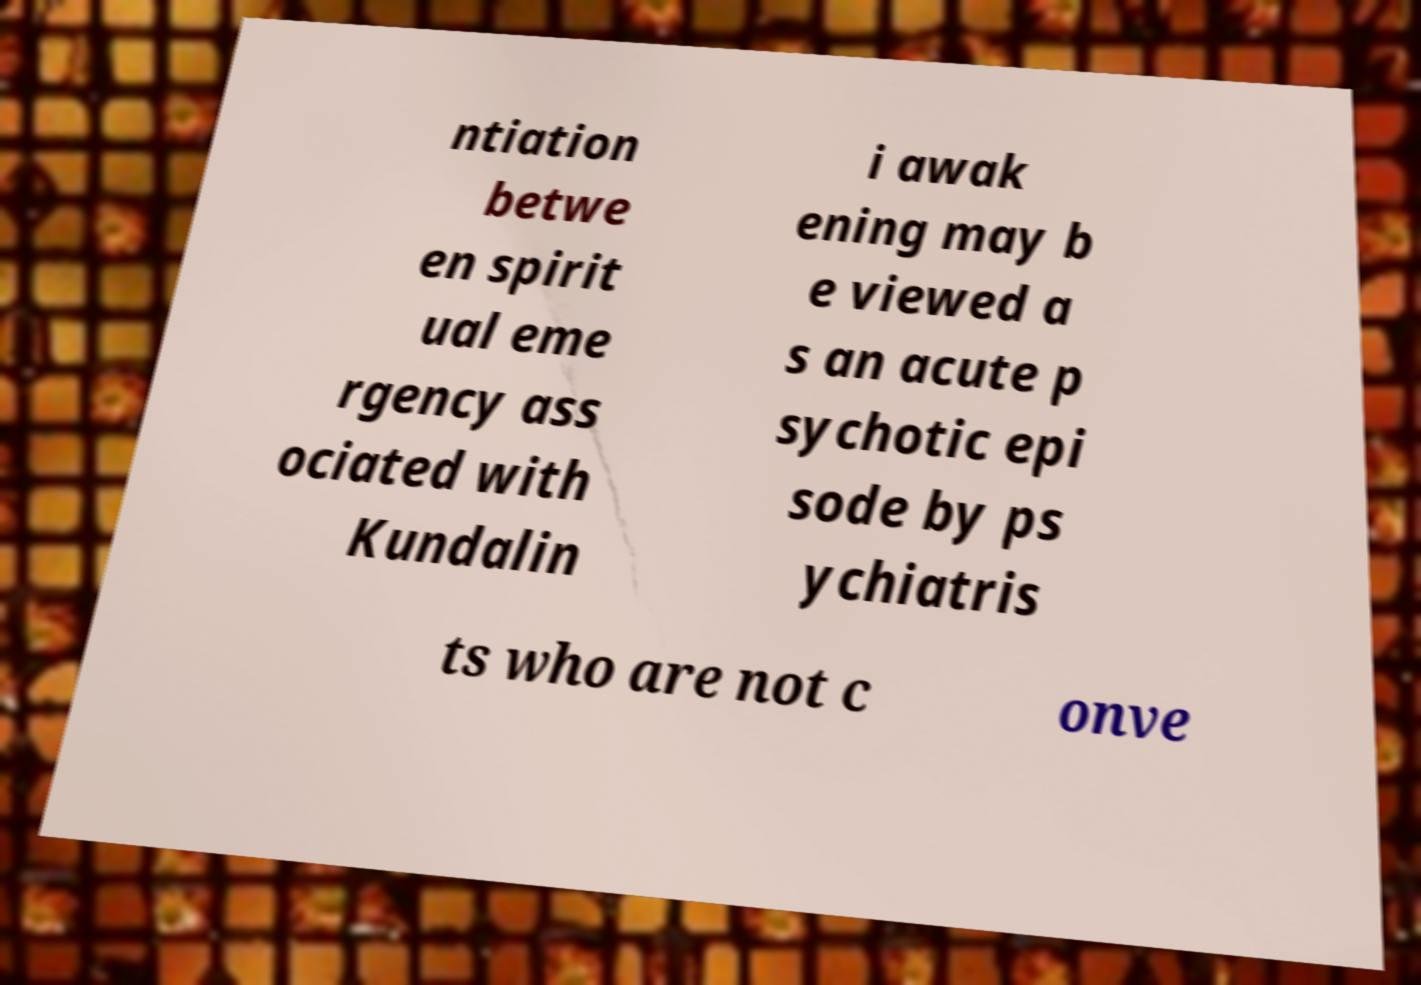Could you assist in decoding the text presented in this image and type it out clearly? ntiation betwe en spirit ual eme rgency ass ociated with Kundalin i awak ening may b e viewed a s an acute p sychotic epi sode by ps ychiatris ts who are not c onve 